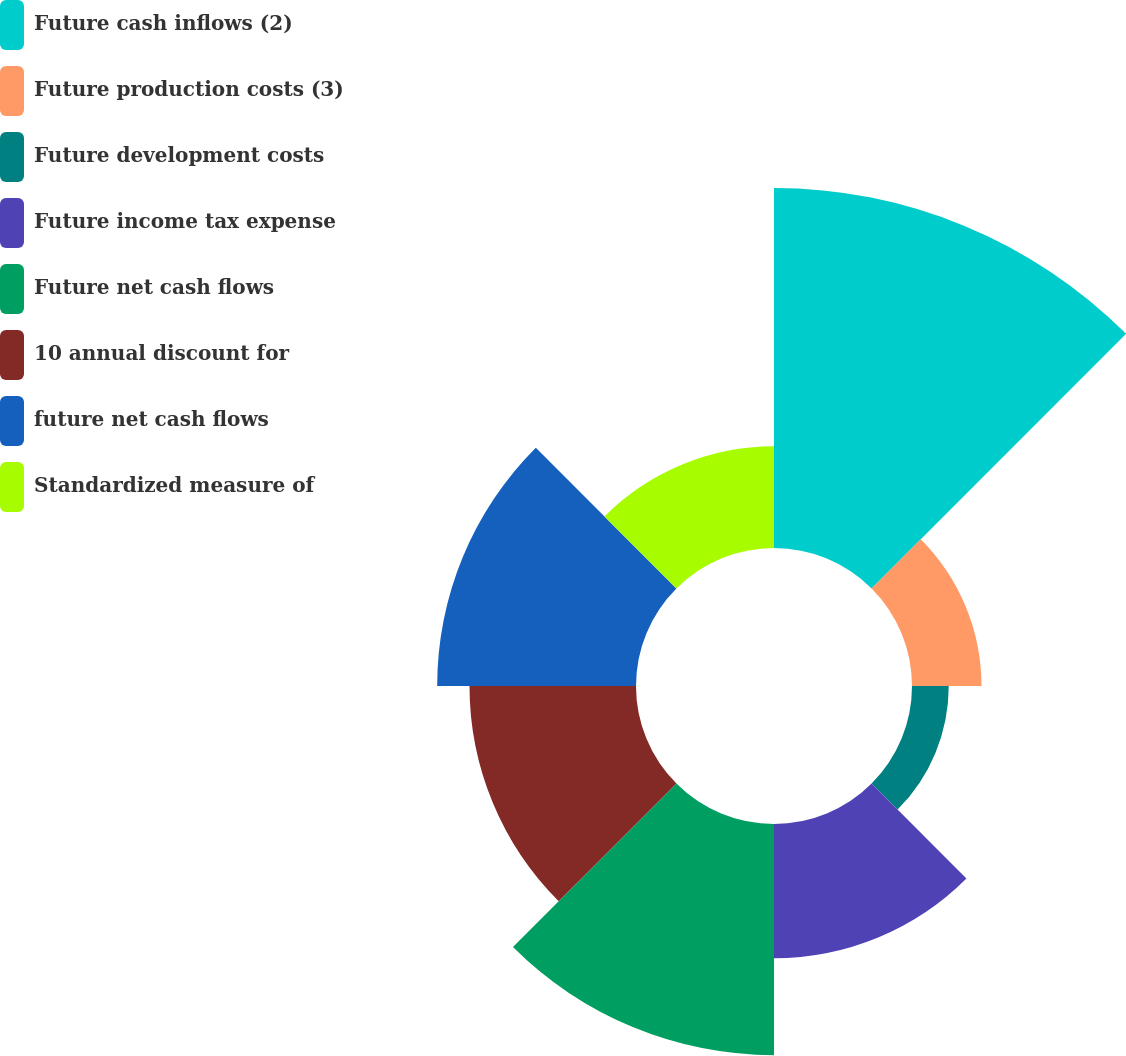<chart> <loc_0><loc_0><loc_500><loc_500><pie_chart><fcel>Future cash inflows (2)<fcel>Future production costs (3)<fcel>Future development costs<fcel>Future income tax expense<fcel>Future net cash flows<fcel>10 annual discount for<fcel>future net cash flows<fcel>Standardized measure of<nl><fcel>27.72%<fcel>5.35%<fcel>2.83%<fcel>10.33%<fcel>17.8%<fcel>12.82%<fcel>15.31%<fcel>7.84%<nl></chart> 